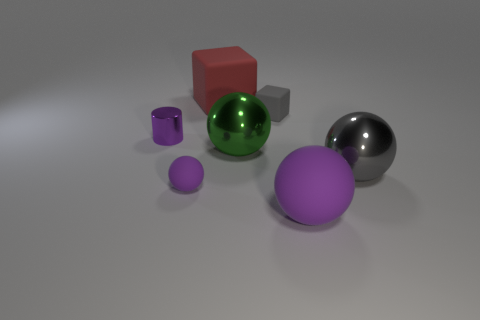The objects appear to be on a surface; can you tell me about the surface texture and lighting? The surface beneath the objects is smooth and features a gentle gradient, with a primarily grey hue that darkens toward the edges. The lighting is soft and diffused, casting subtle shadows directly beneath the objects, suggesting an overhead light source and contributing to the serene atmosphere of the scene. 